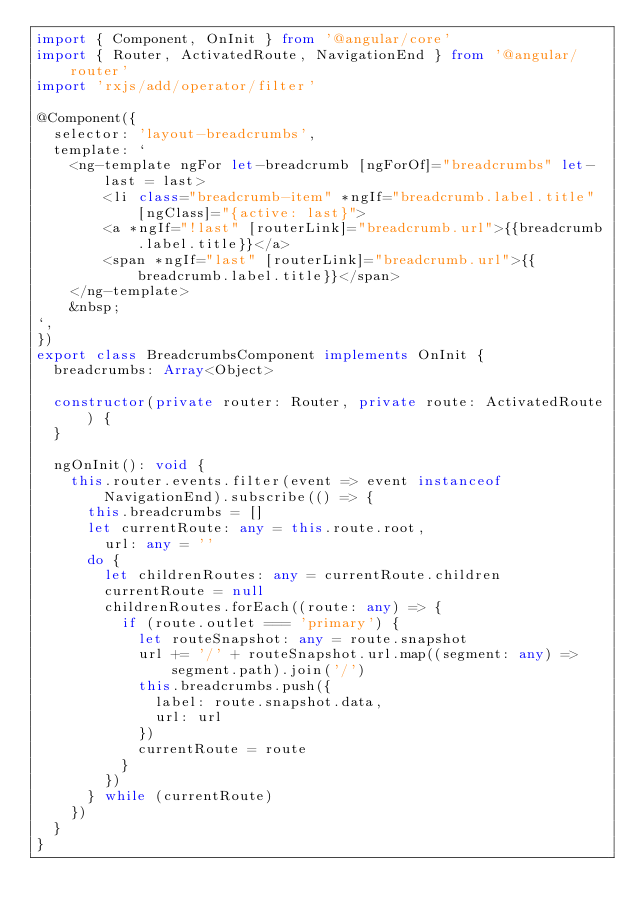Convert code to text. <code><loc_0><loc_0><loc_500><loc_500><_TypeScript_>import { Component, OnInit } from '@angular/core'
import { Router, ActivatedRoute, NavigationEnd } from '@angular/router'
import 'rxjs/add/operator/filter'

@Component({
  selector: 'layout-breadcrumbs',
  template: `
    <ng-template ngFor let-breadcrumb [ngForOf]="breadcrumbs" let-last = last>
        <li class="breadcrumb-item" *ngIf="breadcrumb.label.title" [ngClass]="{active: last}">
        <a *ngIf="!last" [routerLink]="breadcrumb.url">{{breadcrumb.label.title}}</a>
        <span *ngIf="last" [routerLink]="breadcrumb.url">{{breadcrumb.label.title}}</span>
    </ng-template>
    &nbsp;
`,
})
export class BreadcrumbsComponent implements OnInit {
  breadcrumbs: Array<Object>

  constructor(private router: Router, private route: ActivatedRoute) {
  }

  ngOnInit(): void {
    this.router.events.filter(event => event instanceof NavigationEnd).subscribe(() => {
      this.breadcrumbs = []
      let currentRoute: any = this.route.root,
        url: any = ''
      do {
        let childrenRoutes: any = currentRoute.children
        currentRoute = null
        childrenRoutes.forEach((route: any) => {
          if (route.outlet === 'primary') {
            let routeSnapshot: any = route.snapshot
            url += '/' + routeSnapshot.url.map((segment: any) => segment.path).join('/')
            this.breadcrumbs.push({
              label: route.snapshot.data,
              url: url
            })
            currentRoute = route
          }
        })
      } while (currentRoute)
    })
  }
}
</code> 